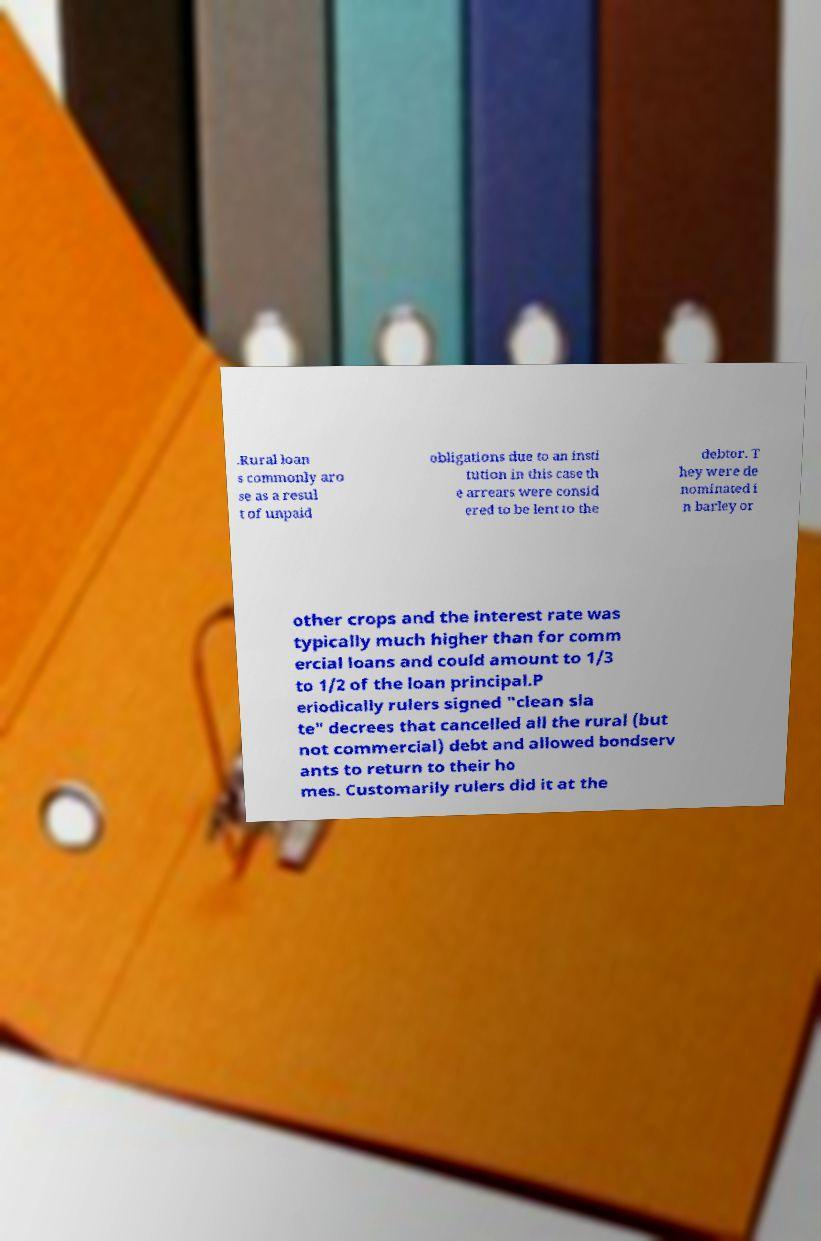Can you accurately transcribe the text from the provided image for me? .Rural loan s commonly aro se as a resul t of unpaid obligations due to an insti tution in this case th e arrears were consid ered to be lent to the debtor. T hey were de nominated i n barley or other crops and the interest rate was typically much higher than for comm ercial loans and could amount to 1/3 to 1/2 of the loan principal.P eriodically rulers signed "clean sla te" decrees that cancelled all the rural (but not commercial) debt and allowed bondserv ants to return to their ho mes. Customarily rulers did it at the 